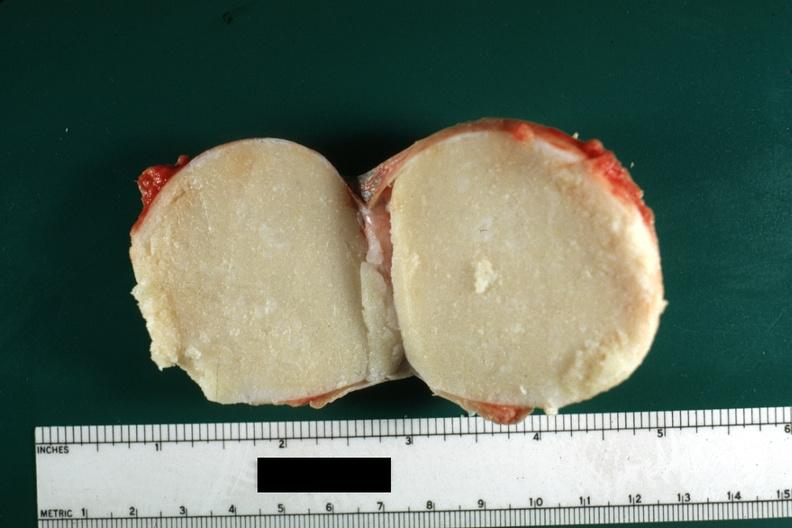what is present?
Answer the question using a single word or phrase. Sebaceous cyst 